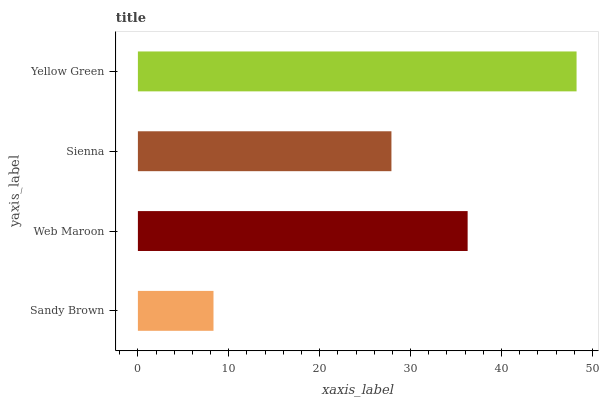Is Sandy Brown the minimum?
Answer yes or no. Yes. Is Yellow Green the maximum?
Answer yes or no. Yes. Is Web Maroon the minimum?
Answer yes or no. No. Is Web Maroon the maximum?
Answer yes or no. No. Is Web Maroon greater than Sandy Brown?
Answer yes or no. Yes. Is Sandy Brown less than Web Maroon?
Answer yes or no. Yes. Is Sandy Brown greater than Web Maroon?
Answer yes or no. No. Is Web Maroon less than Sandy Brown?
Answer yes or no. No. Is Web Maroon the high median?
Answer yes or no. Yes. Is Sienna the low median?
Answer yes or no. Yes. Is Yellow Green the high median?
Answer yes or no. No. Is Yellow Green the low median?
Answer yes or no. No. 